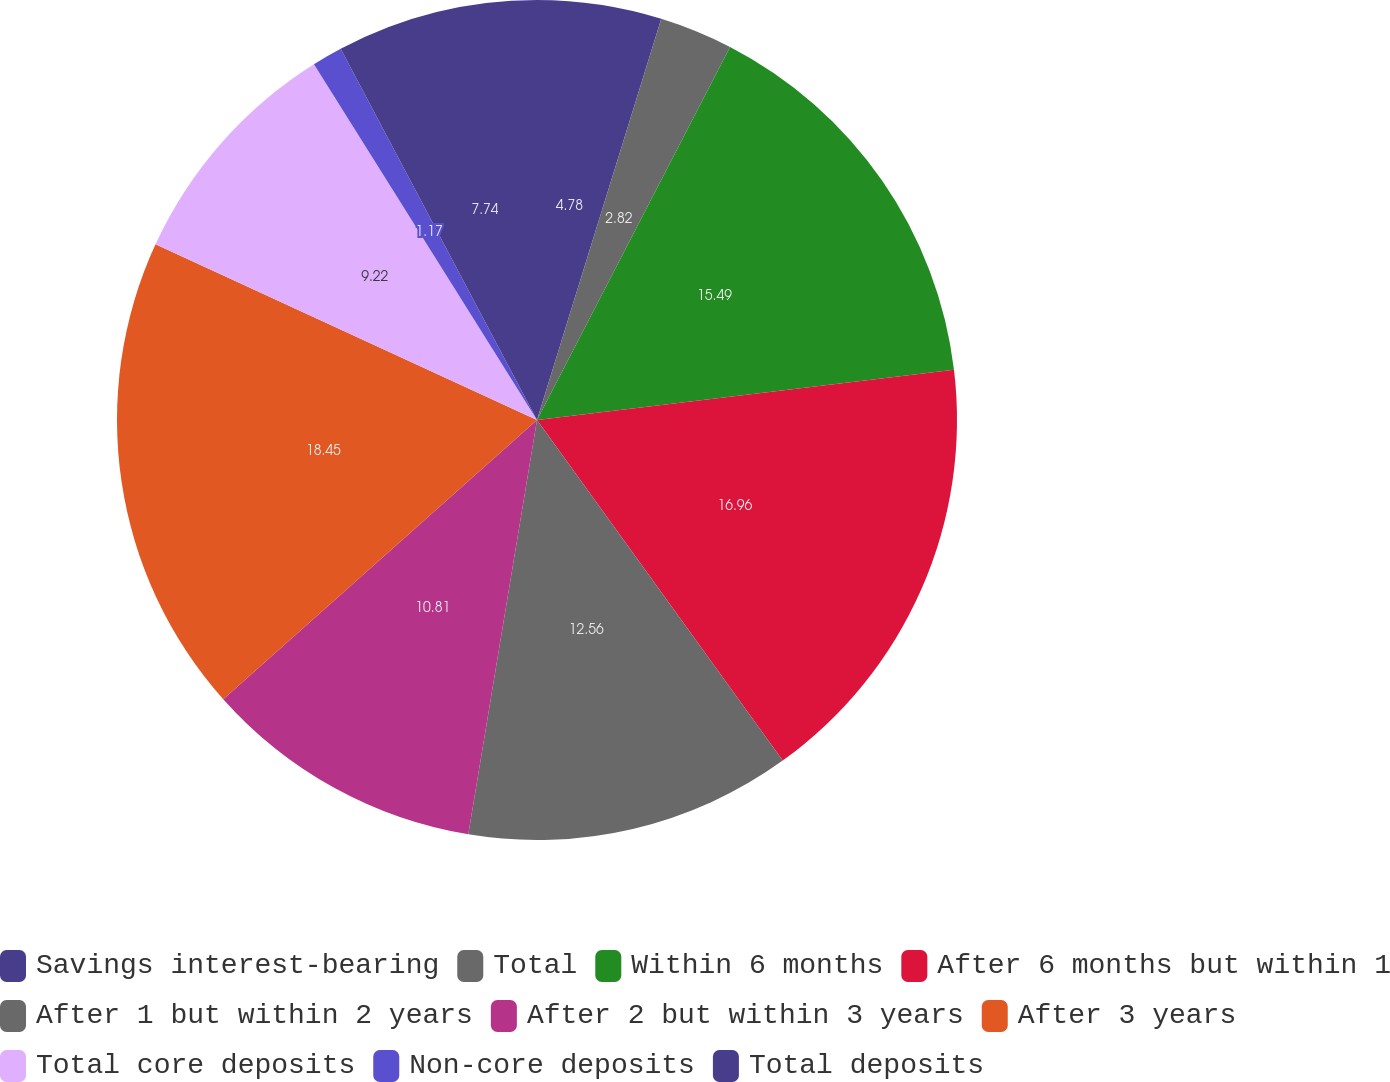Convert chart. <chart><loc_0><loc_0><loc_500><loc_500><pie_chart><fcel>Savings interest-bearing<fcel>Total<fcel>Within 6 months<fcel>After 6 months but within 1<fcel>After 1 but within 2 years<fcel>After 2 but within 3 years<fcel>After 3 years<fcel>Total core deposits<fcel>Non-core deposits<fcel>Total deposits<nl><fcel>4.78%<fcel>2.82%<fcel>15.49%<fcel>16.96%<fcel>12.56%<fcel>10.81%<fcel>18.44%<fcel>9.22%<fcel>1.17%<fcel>7.74%<nl></chart> 